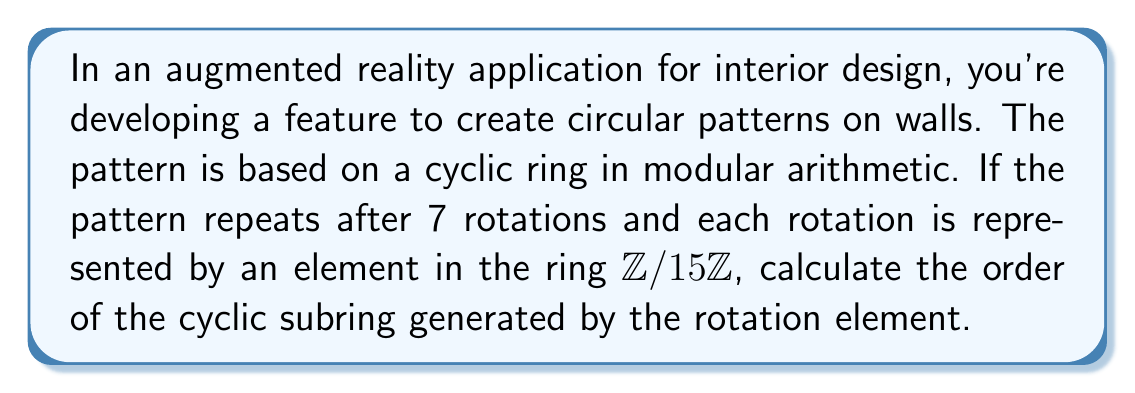What is the answer to this math problem? Let's approach this step-by-step:

1) In the ring $\mathbb{Z}/15\mathbb{Z}$, we're looking at a cyclic subring generated by some element $a$.

2) We're told that the pattern repeats after 7 rotations. This means that $7a \equiv 0 \pmod{15}$.

3) To find the order of the cyclic subring, we need to find the smallest positive integer $n$ such that $na \equiv 0 \pmod{15}$.

4) We can express this as a linear congruence:
   $7x \equiv 0 \pmod{15}$

5) To solve this, we need to find the greatest common divisor (GCD) of 7 and 15:
   $\gcd(7,15) = 1$

6) Since the GCD is 1, the smallest solution to the congruence is when $x = 15$.

7) This means that $15a \equiv 0 \pmod{15}$, and no smaller positive multiple of $a$ will be congruent to 0 mod 15.

8) Therefore, the order of the cyclic subring generated by $a$ is 15.

In the context of the AR application, this means that while the visual pattern repeats every 7 rotations, the underlying mathematical structure (the cyclic subring) completes a full cycle after 15 rotations.
Answer: The order of the cyclic subring is 15. 